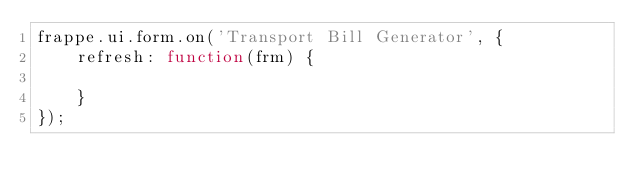<code> <loc_0><loc_0><loc_500><loc_500><_JavaScript_>frappe.ui.form.on('Transport Bill Generator', {
	refresh: function(frm) {

	}
});
</code> 